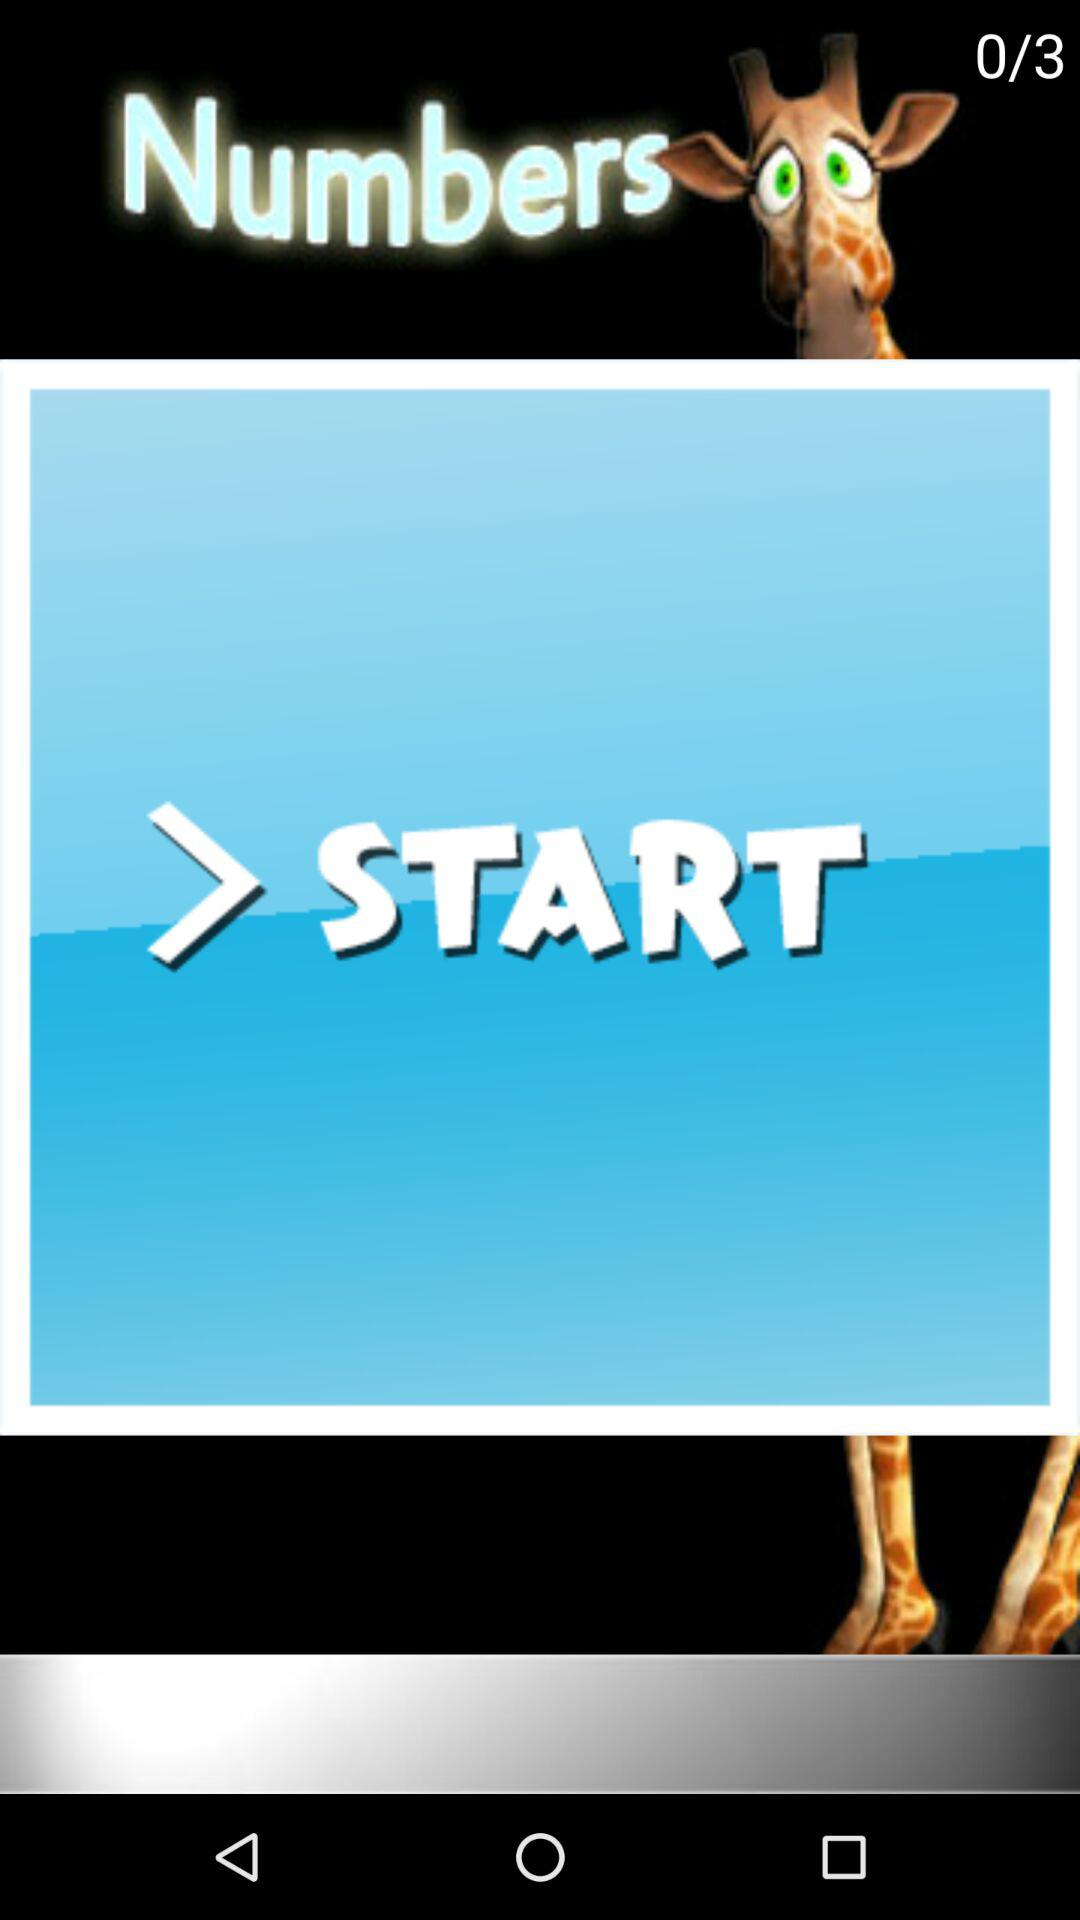Which step am I on? You are on step 0. 